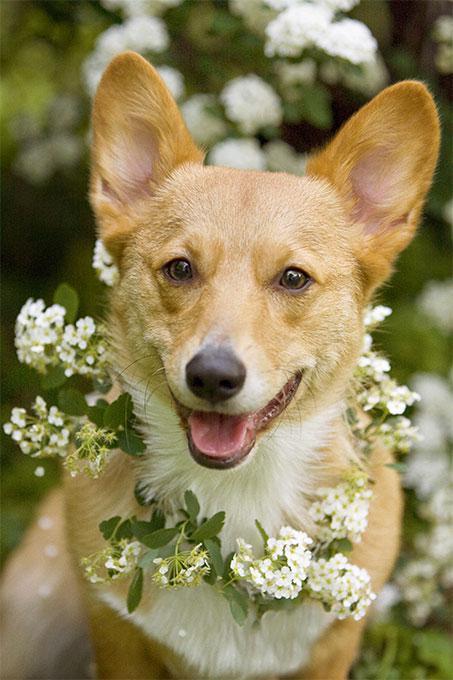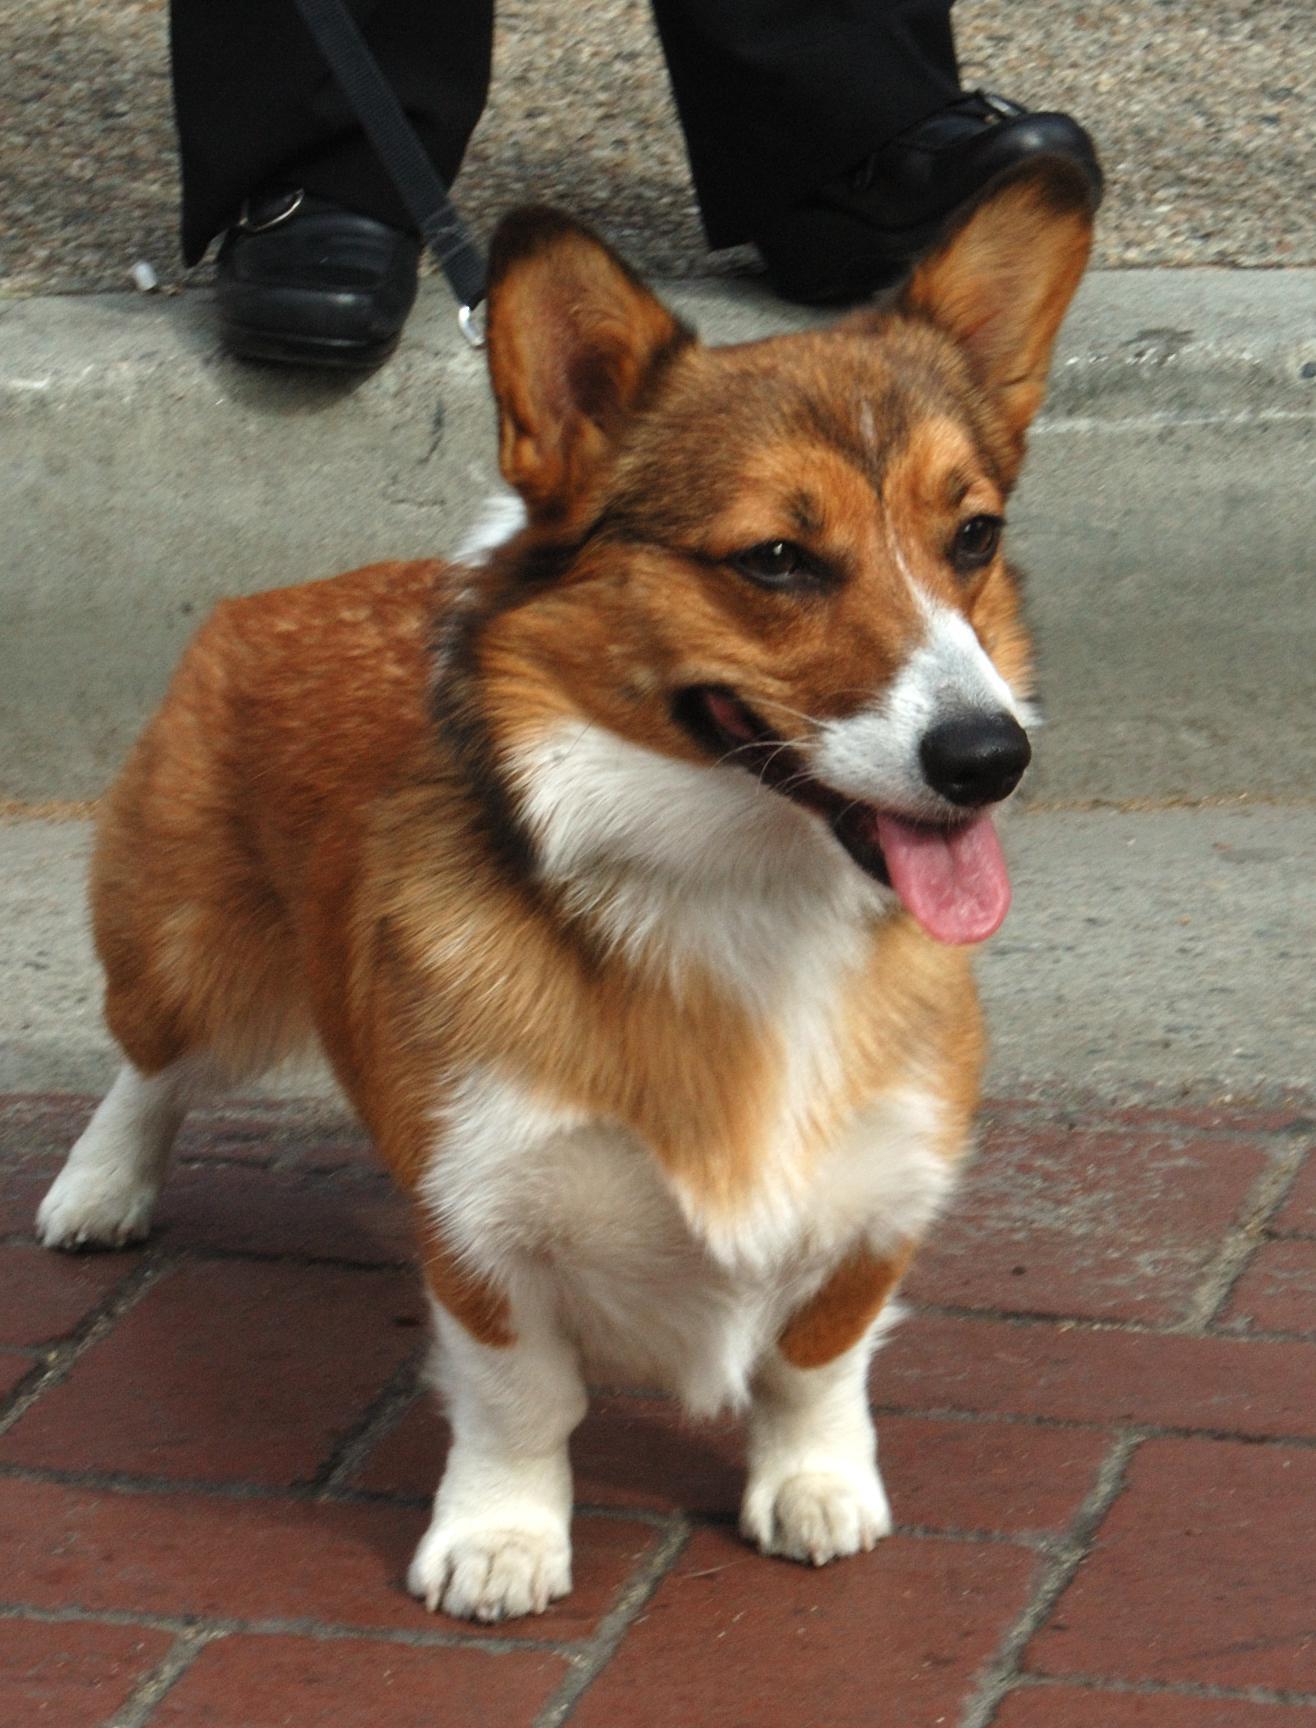The first image is the image on the left, the second image is the image on the right. Analyze the images presented: Is the assertion "The dog in the right image is not posed with grass in the background." valid? Answer yes or no. Yes. 